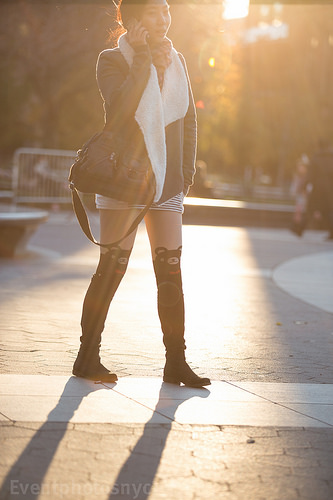<image>
Can you confirm if the bear socks is on the knee? Yes. Looking at the image, I can see the bear socks is positioned on top of the knee, with the knee providing support. 